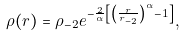<formula> <loc_0><loc_0><loc_500><loc_500>\rho ( r ) = \rho _ { - 2 } e ^ { - \frac { 2 } { \alpha } \left [ \left ( \frac { r } { r _ { - 2 } } \right ) ^ { \alpha } - 1 \right ] } ,</formula> 